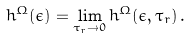<formula> <loc_0><loc_0><loc_500><loc_500>h ^ { \Omega } ( \epsilon ) = \lim _ { \tau _ { r } \to 0 } h ^ { \Omega } ( \epsilon , \tau _ { r } ) \, .</formula> 